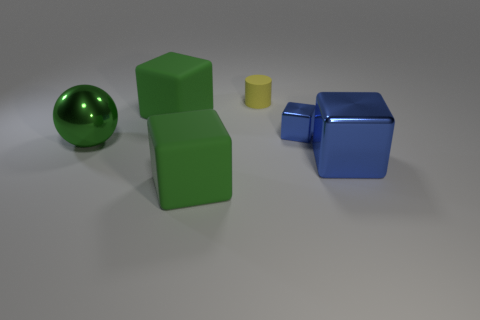Do the big matte block behind the big metal ball and the metallic sphere have the same color?
Offer a very short reply. Yes. How many objects are either big blue blocks on the right side of the green metal ball or yellow shiny objects?
Offer a very short reply. 1. What material is the green block that is behind the large green cube in front of the tiny metallic object that is behind the large metal cube made of?
Make the answer very short. Rubber. Are there more large objects that are in front of the large blue metal thing than small yellow rubber cylinders that are in front of the yellow matte cylinder?
Provide a short and direct response. Yes. What number of cylinders are either big green things or green metallic things?
Your answer should be compact. 0. There is a large green rubber object in front of the large metallic object that is on the left side of the small rubber thing; how many tiny blue blocks are in front of it?
Provide a succinct answer. 0. What is the material of the big cube that is the same color as the tiny metal thing?
Provide a short and direct response. Metal. Is the number of purple metal blocks greater than the number of large blue blocks?
Your response must be concise. No. Do the green sphere and the yellow object have the same size?
Provide a succinct answer. No. What number of things are either blue cubes or large things?
Your response must be concise. 5. 